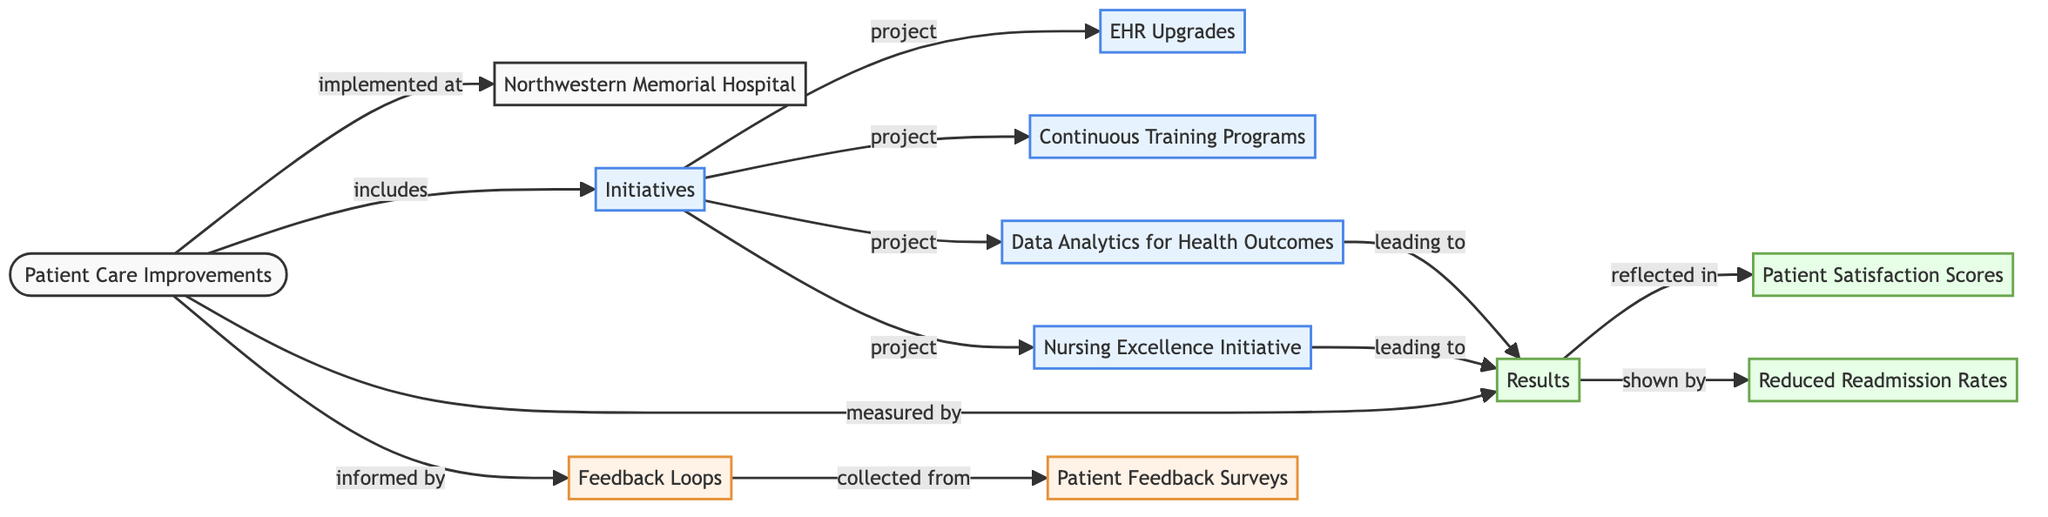What are the key initiatives listed under patient care improvements? The diagram indicates that the initiatives include Electronic Health Records Upgrades, Continuous Training Programs, Data Analytics for Health Outcomes, and Nursing Excellence Initiative. These are the nodes that are directly linked to the "Initiatives" node.
Answer: Electronic Health Records Upgrades, Continuous Training Programs, Data Analytics for Health Outcomes, Nursing Excellence Initiative How many nodes are in the diagram? The diagram consists of 12 nodes, each representing different aspects of patient care improvements at Northwestern Medicine, as indicated by the list of nodes provided.
Answer: 12 What measure reflects the results of patient care improvements? The results are reflected in Patient Satisfaction Scores and Reduced Readmission Rates, as represented by the edges leading from the "Results" node to these respective nodes.
Answer: Patient Satisfaction Scores, Reduced Readmission Rates Which node leads to the results in the feedback loops? The Nursing Excellence Initiative and Data Analytics for Health Outcomes both lead to the "Results" node, indicating that they contribute to measuring the outcomes of patient care improvements.
Answer: Nursing Excellence Initiative, Data Analytics for Health Outcomes How is patient feedback collected for the feedback loops? The patient feedback is collected through Patient Feedback Surveys, which is directly linked to the "Feedback Loops" node in the diagram.
Answer: Patient Feedback Surveys Which initiative has a relationship showing a direct project link with EHR upgrades? The "Initiatives" node has a direct project link to the "Electronic Health Records (EHR) Upgrades," indicating that it is one of the projects under patient care improvements.
Answer: Electronic Health Records (EHR) Upgrades What is the relationship between the Nursing Excellence Initiative and the Results? The relationship shows that the Nursing Excellence Initiative leads to the Results node, indicating that the initiative has a positive impact on patient care outcomes.
Answer: leading to How many feedback loops are mentioned in the diagram? There is one node labeled as "Feedback Loops," but it represents multiple sources of feedback collected from the surveys, showing that patient feedback is utilized in the improvement process.
Answer: 1 What is the purpose of data analytics in the context of this diagram? The purpose of data analytics is to inform the healthcare outcomes and contribute to the effectiveness of patient care initiatives, as indicated by its direct link to the "Results" node.
Answer: inform healthcare outcomes 